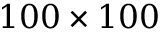Convert formula to latex. <formula><loc_0><loc_0><loc_500><loc_500>1 0 0 \times 1 0 0</formula> 